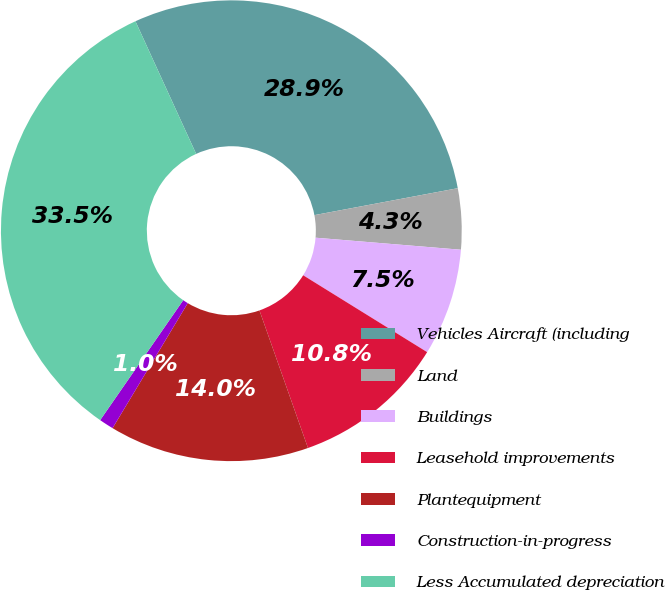Convert chart to OTSL. <chart><loc_0><loc_0><loc_500><loc_500><pie_chart><fcel>Vehicles Aircraft (including<fcel>Land<fcel>Buildings<fcel>Leasehold improvements<fcel>Plantequipment<fcel>Construction-in-progress<fcel>Less Accumulated depreciation<nl><fcel>28.88%<fcel>4.27%<fcel>7.52%<fcel>10.77%<fcel>14.02%<fcel>1.02%<fcel>33.53%<nl></chart> 